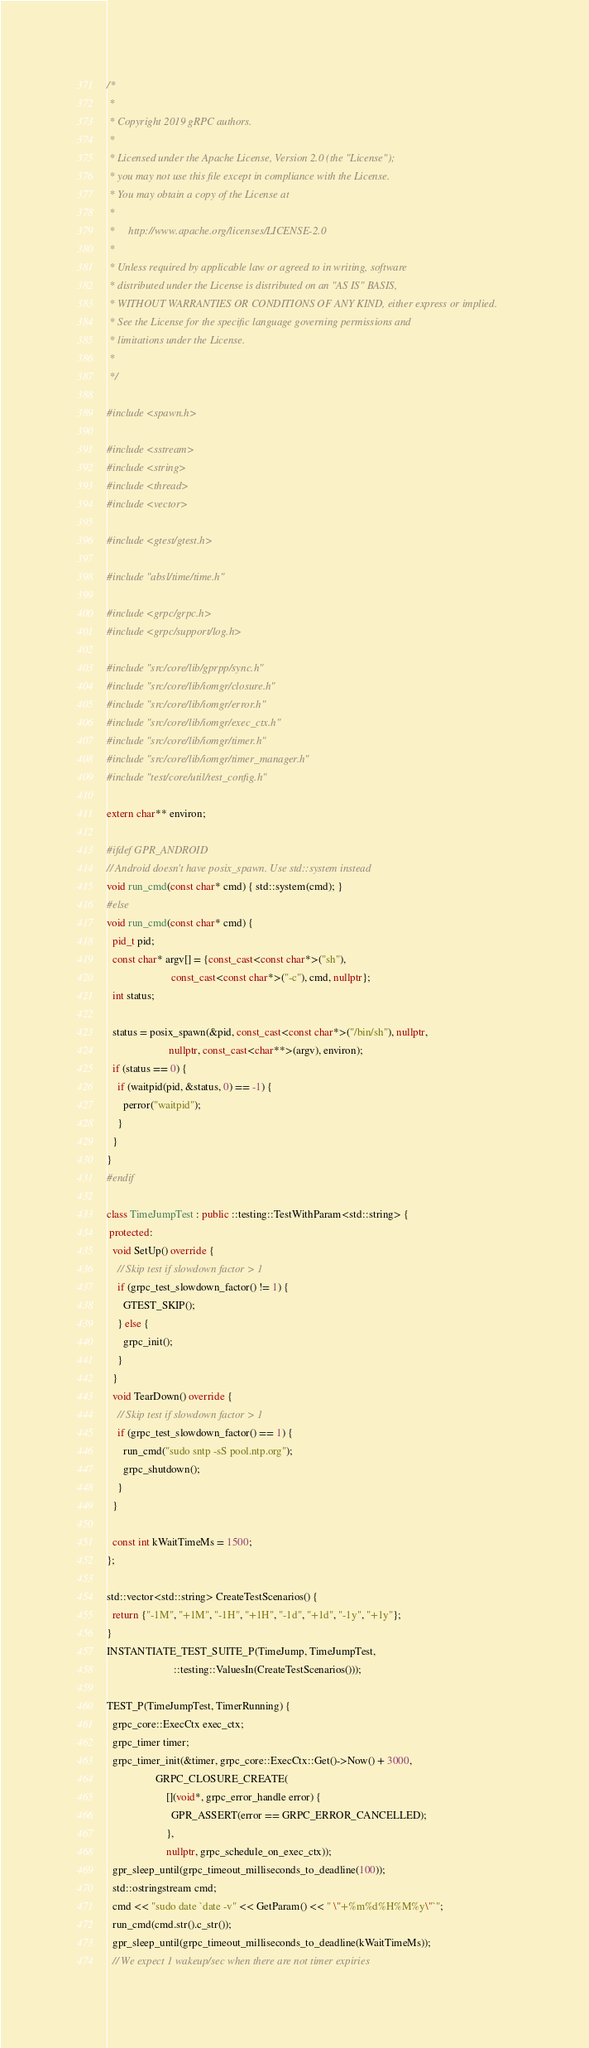Convert code to text. <code><loc_0><loc_0><loc_500><loc_500><_C++_>/*
 *
 * Copyright 2019 gRPC authors.
 *
 * Licensed under the Apache License, Version 2.0 (the "License");
 * you may not use this file except in compliance with the License.
 * You may obtain a copy of the License at
 *
 *     http://www.apache.org/licenses/LICENSE-2.0
 *
 * Unless required by applicable law or agreed to in writing, software
 * distributed under the License is distributed on an "AS IS" BASIS,
 * WITHOUT WARRANTIES OR CONDITIONS OF ANY KIND, either express or implied.
 * See the License for the specific language governing permissions and
 * limitations under the License.
 *
 */

#include <spawn.h>

#include <sstream>
#include <string>
#include <thread>
#include <vector>

#include <gtest/gtest.h>

#include "absl/time/time.h"

#include <grpc/grpc.h>
#include <grpc/support/log.h>

#include "src/core/lib/gprpp/sync.h"
#include "src/core/lib/iomgr/closure.h"
#include "src/core/lib/iomgr/error.h"
#include "src/core/lib/iomgr/exec_ctx.h"
#include "src/core/lib/iomgr/timer.h"
#include "src/core/lib/iomgr/timer_manager.h"
#include "test/core/util/test_config.h"

extern char** environ;

#ifdef GPR_ANDROID
// Android doesn't have posix_spawn. Use std::system instead
void run_cmd(const char* cmd) { std::system(cmd); }
#else
void run_cmd(const char* cmd) {
  pid_t pid;
  const char* argv[] = {const_cast<const char*>("sh"),
                        const_cast<const char*>("-c"), cmd, nullptr};
  int status;

  status = posix_spawn(&pid, const_cast<const char*>("/bin/sh"), nullptr,
                       nullptr, const_cast<char**>(argv), environ);
  if (status == 0) {
    if (waitpid(pid, &status, 0) == -1) {
      perror("waitpid");
    }
  }
}
#endif

class TimeJumpTest : public ::testing::TestWithParam<std::string> {
 protected:
  void SetUp() override {
    // Skip test if slowdown factor > 1
    if (grpc_test_slowdown_factor() != 1) {
      GTEST_SKIP();
    } else {
      grpc_init();
    }
  }
  void TearDown() override {
    // Skip test if slowdown factor > 1
    if (grpc_test_slowdown_factor() == 1) {
      run_cmd("sudo sntp -sS pool.ntp.org");
      grpc_shutdown();
    }
  }

  const int kWaitTimeMs = 1500;
};

std::vector<std::string> CreateTestScenarios() {
  return {"-1M", "+1M", "-1H", "+1H", "-1d", "+1d", "-1y", "+1y"};
}
INSTANTIATE_TEST_SUITE_P(TimeJump, TimeJumpTest,
                         ::testing::ValuesIn(CreateTestScenarios()));

TEST_P(TimeJumpTest, TimerRunning) {
  grpc_core::ExecCtx exec_ctx;
  grpc_timer timer;
  grpc_timer_init(&timer, grpc_core::ExecCtx::Get()->Now() + 3000,
                  GRPC_CLOSURE_CREATE(
                      [](void*, grpc_error_handle error) {
                        GPR_ASSERT(error == GRPC_ERROR_CANCELLED);
                      },
                      nullptr, grpc_schedule_on_exec_ctx));
  gpr_sleep_until(grpc_timeout_milliseconds_to_deadline(100));
  std::ostringstream cmd;
  cmd << "sudo date `date -v" << GetParam() << " \"+%m%d%H%M%y\"`";
  run_cmd(cmd.str().c_str());
  gpr_sleep_until(grpc_timeout_milliseconds_to_deadline(kWaitTimeMs));
  // We expect 1 wakeup/sec when there are not timer expiries</code> 